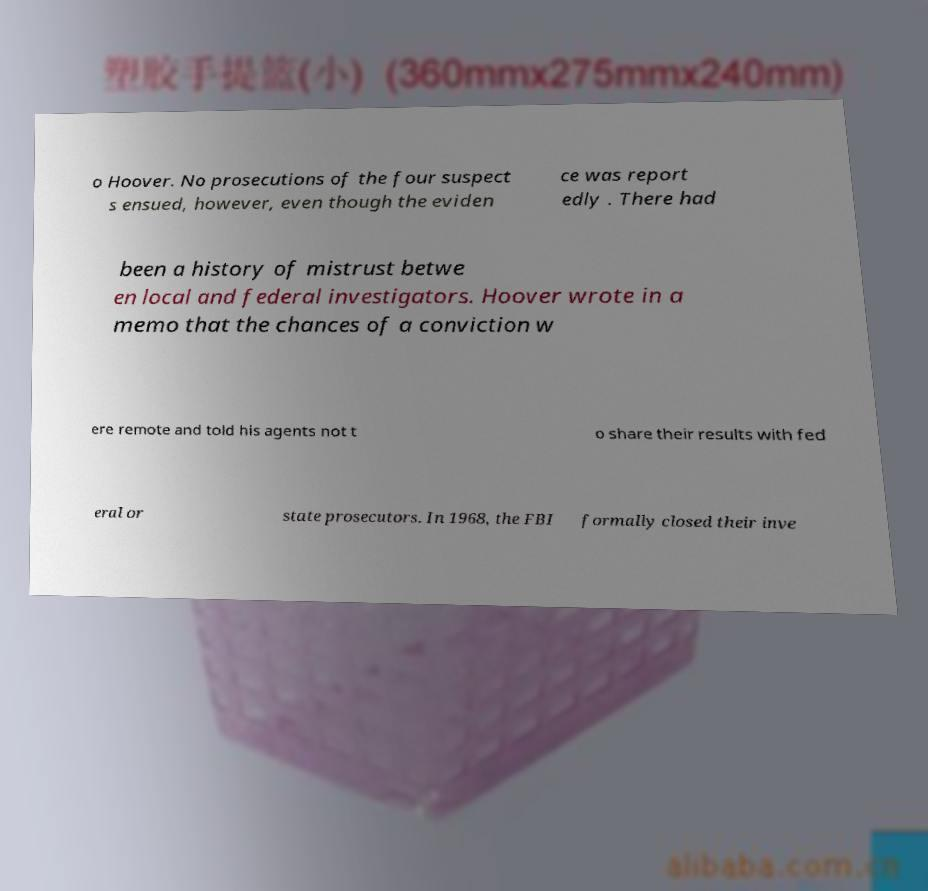Could you extract and type out the text from this image? o Hoover. No prosecutions of the four suspect s ensued, however, even though the eviden ce was report edly . There had been a history of mistrust betwe en local and federal investigators. Hoover wrote in a memo that the chances of a conviction w ere remote and told his agents not t o share their results with fed eral or state prosecutors. In 1968, the FBI formally closed their inve 